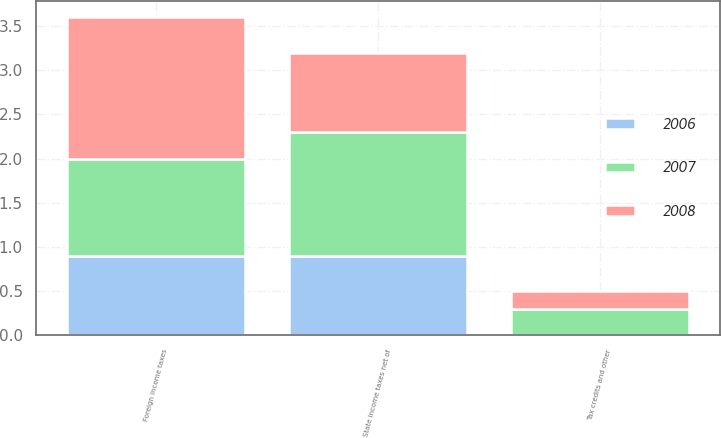<chart> <loc_0><loc_0><loc_500><loc_500><stacked_bar_chart><ecel><fcel>State income taxes net of<fcel>Foreign income taxes<fcel>Tax credits and other<nl><fcel>2007<fcel>1.4<fcel>1.1<fcel>0.3<nl><fcel>2008<fcel>0.9<fcel>1.6<fcel>0.2<nl><fcel>2006<fcel>0.9<fcel>0.9<fcel>0<nl></chart> 